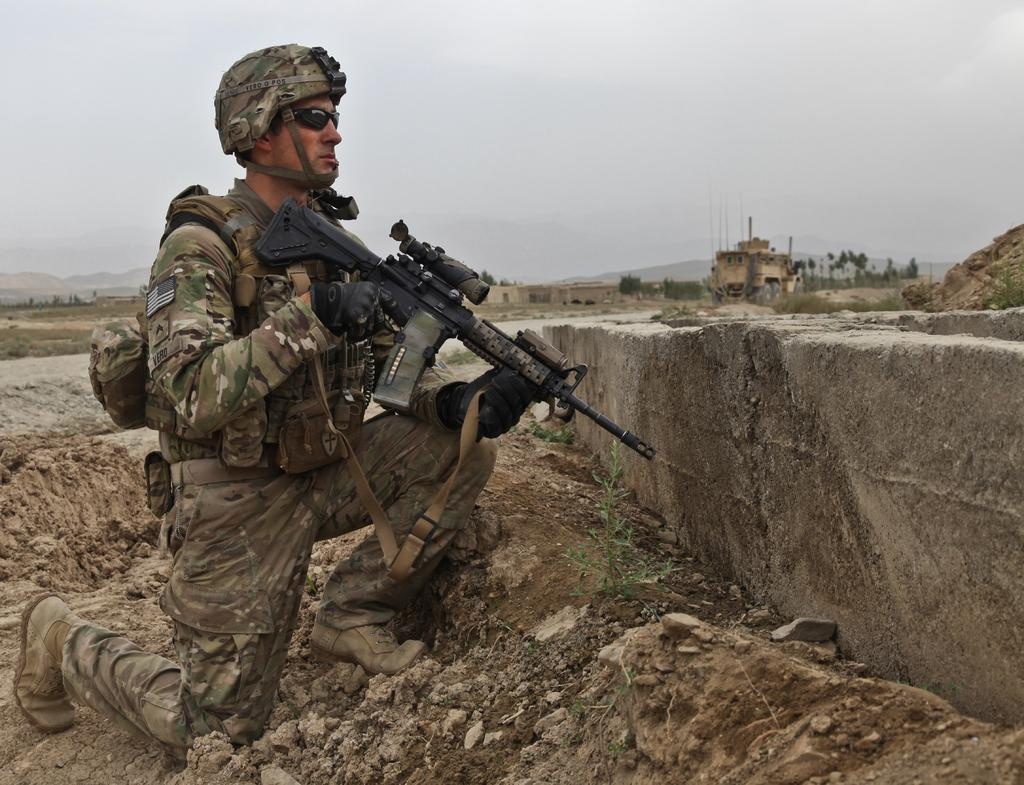What type of person is in the image? There is an army person in the image. What position is the army person in? The army person is sitting on a knee. What is near the army person? The army person is near a wall. How would you describe the terrain in the image? The location has a rocky and muddy surface. What can be seen in the background of the image? There are buildings, trees, hills, and the sky visible in the background of the image. What type of square is visible in the image? There is no square present in the image. What kind of music can be heard in the background of the image? There is no music present in the image, as it is a still photograph. 